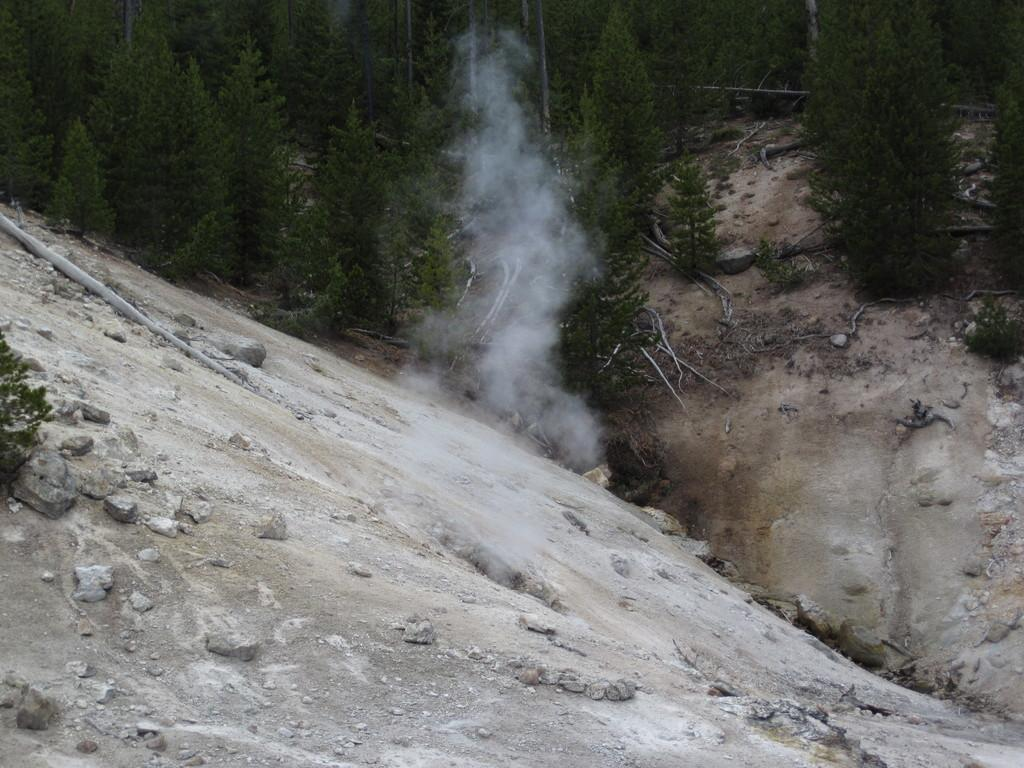What type of vegetation can be seen in the image? There are trees in the image. What geographical features are present in the image? There are hills in the image. How many bananas are hanging from the trees in the image? There are no bananas present in the image; it only features trees and hills. What type of balloon can be seen floating above the hills in the image? There is no balloon present in the image; it only features trees and hills. 